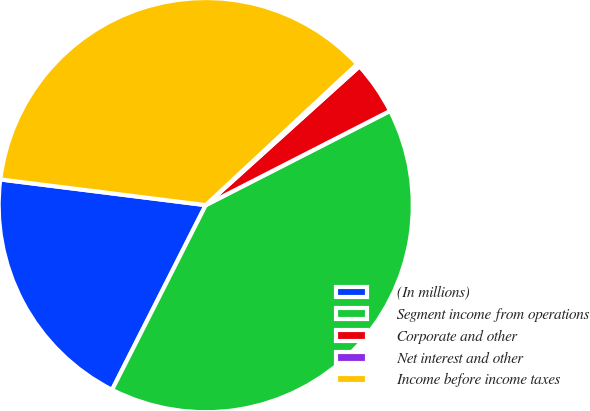Convert chart to OTSL. <chart><loc_0><loc_0><loc_500><loc_500><pie_chart><fcel>(In millions)<fcel>Segment income from operations<fcel>Corporate and other<fcel>Net interest and other<fcel>Income before income taxes<nl><fcel>19.51%<fcel>39.99%<fcel>4.17%<fcel>0.25%<fcel>36.08%<nl></chart> 